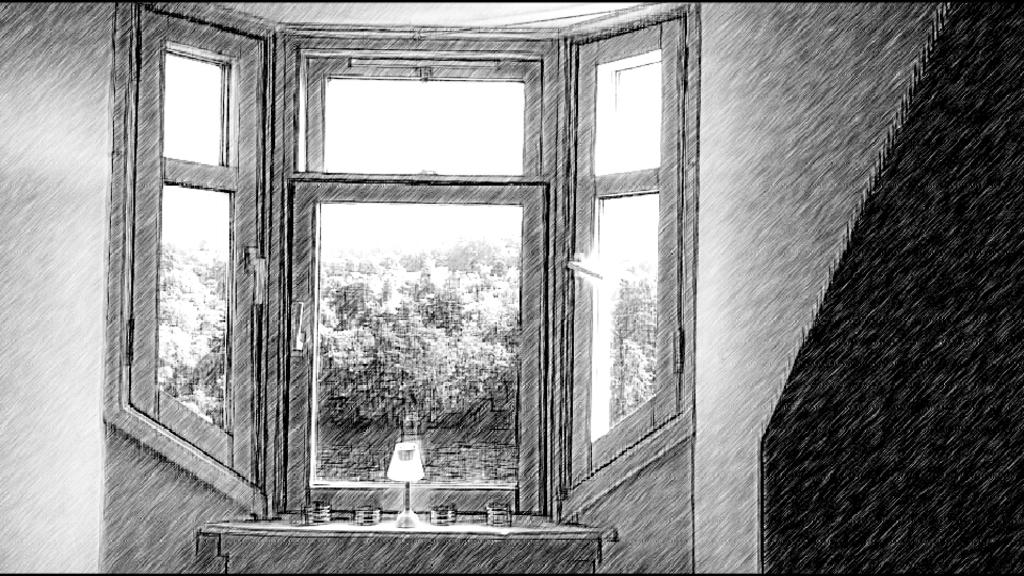What type of architectural feature can be seen in the image? There are windows and a wall visible in the image. Can you describe the unidentified object at the bottom of the image? Unfortunately, the facts provided do not give enough information to describe the unidentified object at the bottom of the image. What type of mist can be seen coming from the bath in the image? There is no bath or mist present in the image. What type of road is visible in the image? There is no road visible in the image. 